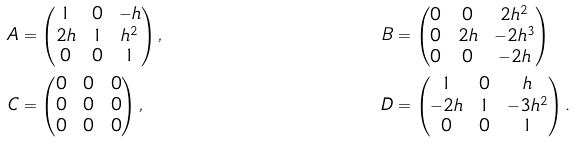Convert formula to latex. <formula><loc_0><loc_0><loc_500><loc_500>A & = \begin{pmatrix} 1 & 0 & - h \\ 2 h & 1 & h ^ { 2 } \\ 0 & 0 & 1 \end{pmatrix} , & B & = \begin{pmatrix} 0 & 0 & 2 h ^ { 2 } \\ 0 & 2 h & - 2 h ^ { 3 } \\ 0 & 0 & - 2 h \end{pmatrix} \\ C & = \begin{pmatrix} 0 & 0 & 0 \\ 0 & 0 & 0 \\ 0 & 0 & 0 \end{pmatrix} , & D & = \begin{pmatrix} 1 & 0 & h \\ - 2 h & 1 & - 3 h ^ { 2 } \\ 0 & 0 & 1 \end{pmatrix} .</formula> 